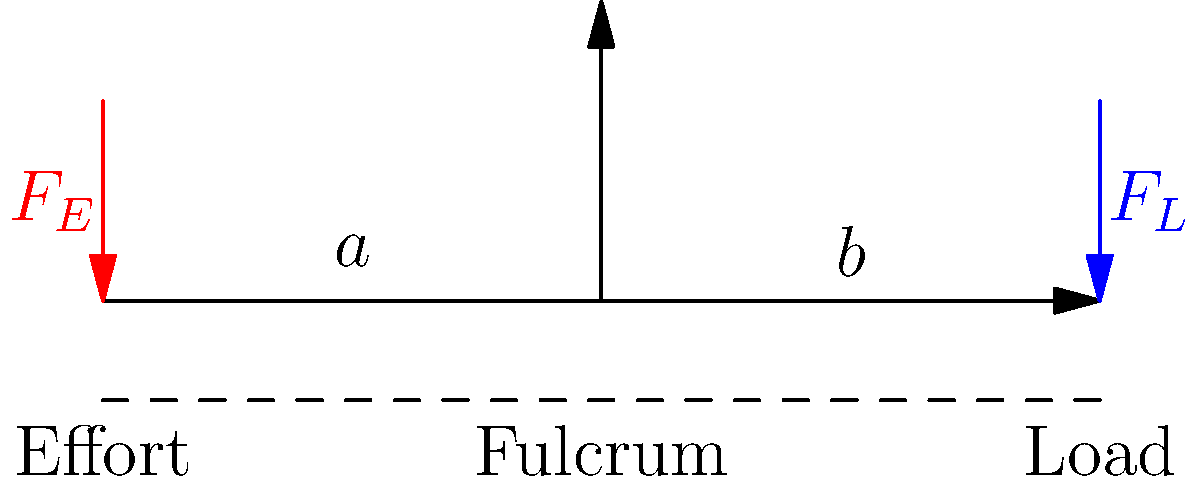In the context of biomechanics, consider the simple machine diagram above representing a first-class lever system in the human body (e.g., the atlanto-occipital joint). If the effort force $F_E$ is 50 N, the load force $F_L$ is 200 N, and the total length of the lever is 10 cm, calculate the mechanical advantage of this system. How does this relate to the concept of economic efficiency that Hans Palmer might have discussed? Let's approach this step-by-step:

1) In a first-class lever system, the mechanical advantage (MA) is given by the ratio of the load arm to the effort arm:

   $MA = \frac{\text{load arm}}{\text{effort arm}} = \frac{a}{b}$

2) We can also express MA as the ratio of the effort force to the load force:

   $MA = \frac{F_L}{F_E}$

3) Given:
   $F_E = 50$ N
   $F_L = 200$ N
   Total length = 10 cm

4) Calculate MA using forces:

   $MA = \frac{F_L}{F_E} = \frac{200}{50} = 4$

5) This means the load arm must be 4 times longer than the effort arm.

6) If we denote the effort arm as $x$, then:
   $x + 4x = 10$ cm
   $5x = 10$ cm
   $x = 2$ cm

7) So, the effort arm is 2 cm and the load arm is 8 cm.

Relating to economics:
This system demonstrates the trade-off between force and distance, similar to economic trade-offs Hans Palmer might have discussed. The system gains a mechanical advantage (like economic efficiency) by sacrificing distance (analogous to time or resources in economics). Just as economists seek to optimize resource allocation, biomechanics seeks to optimize force distribution in the body.
Answer: Mechanical Advantage = 4 